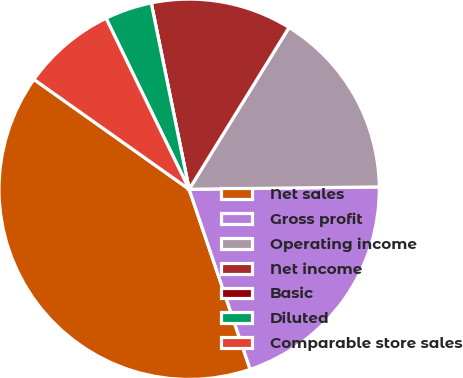Convert chart. <chart><loc_0><loc_0><loc_500><loc_500><pie_chart><fcel>Net sales<fcel>Gross profit<fcel>Operating income<fcel>Net income<fcel>Basic<fcel>Diluted<fcel>Comparable store sales<nl><fcel>40.0%<fcel>20.0%<fcel>16.0%<fcel>12.0%<fcel>0.0%<fcel>4.0%<fcel>8.0%<nl></chart> 